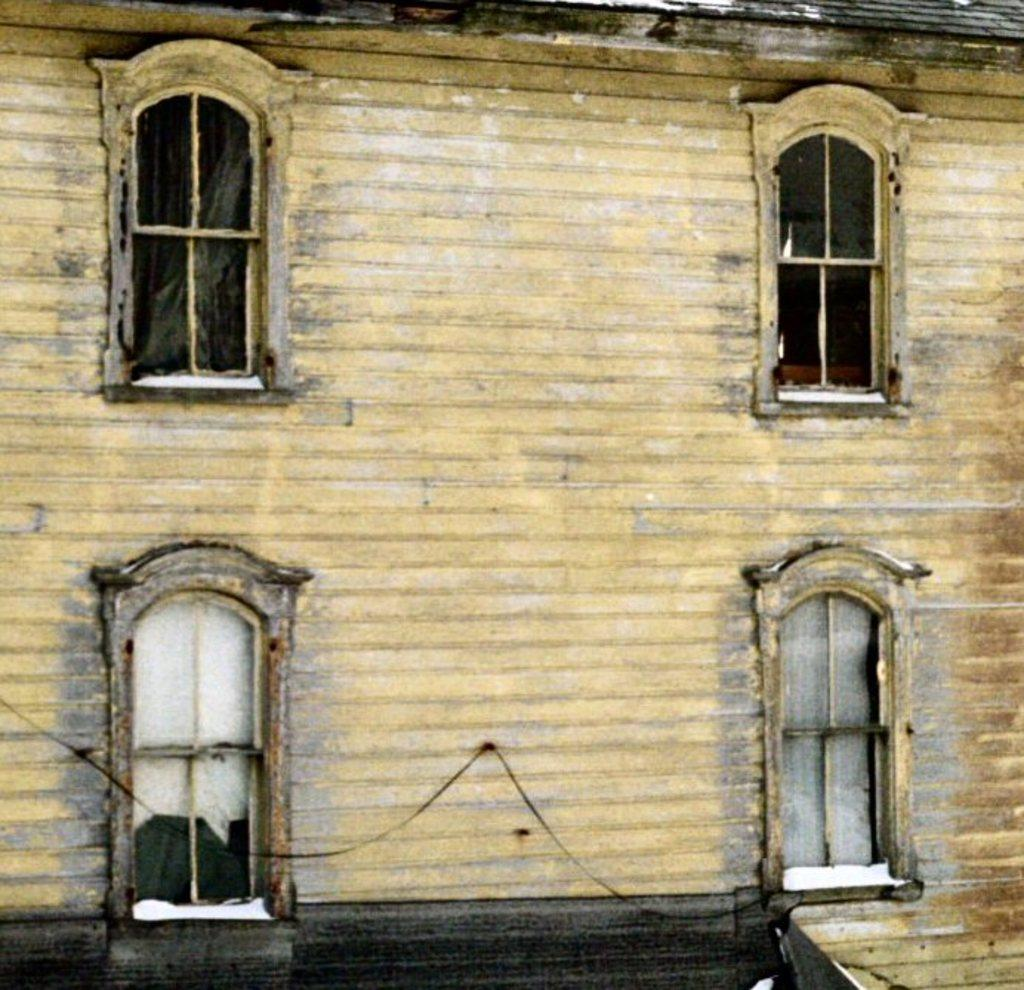What type of structure is present in the image? There is a building or a wall in the image. What is the color of the building or wall? The building or wall is in light yellow color. What feature can be seen on the building or wall? The building or wall has windows. What is the color of the bottom part of the building or wall? The bottom part of the building or wall is black in color. How does the van contribute to the division of the building or wall in the image? There is no van present in the image, so it cannot contribute to the division of the building or wall. 